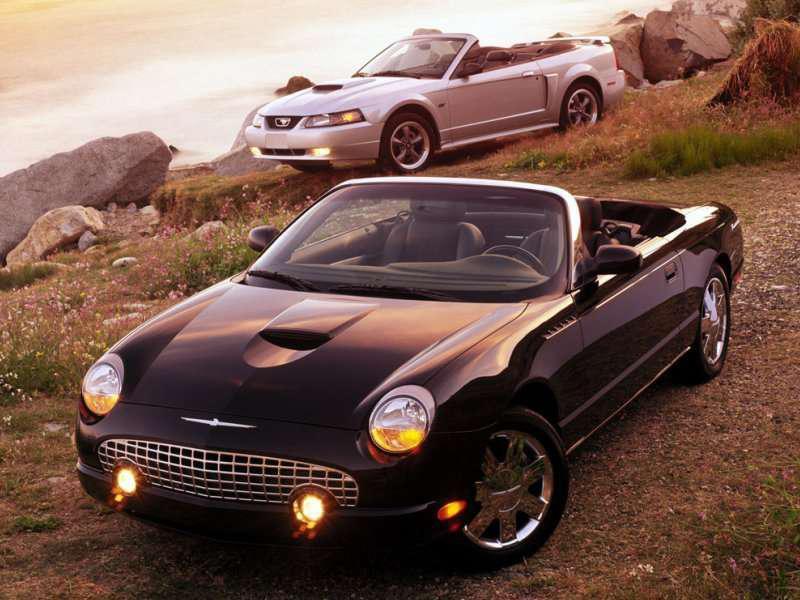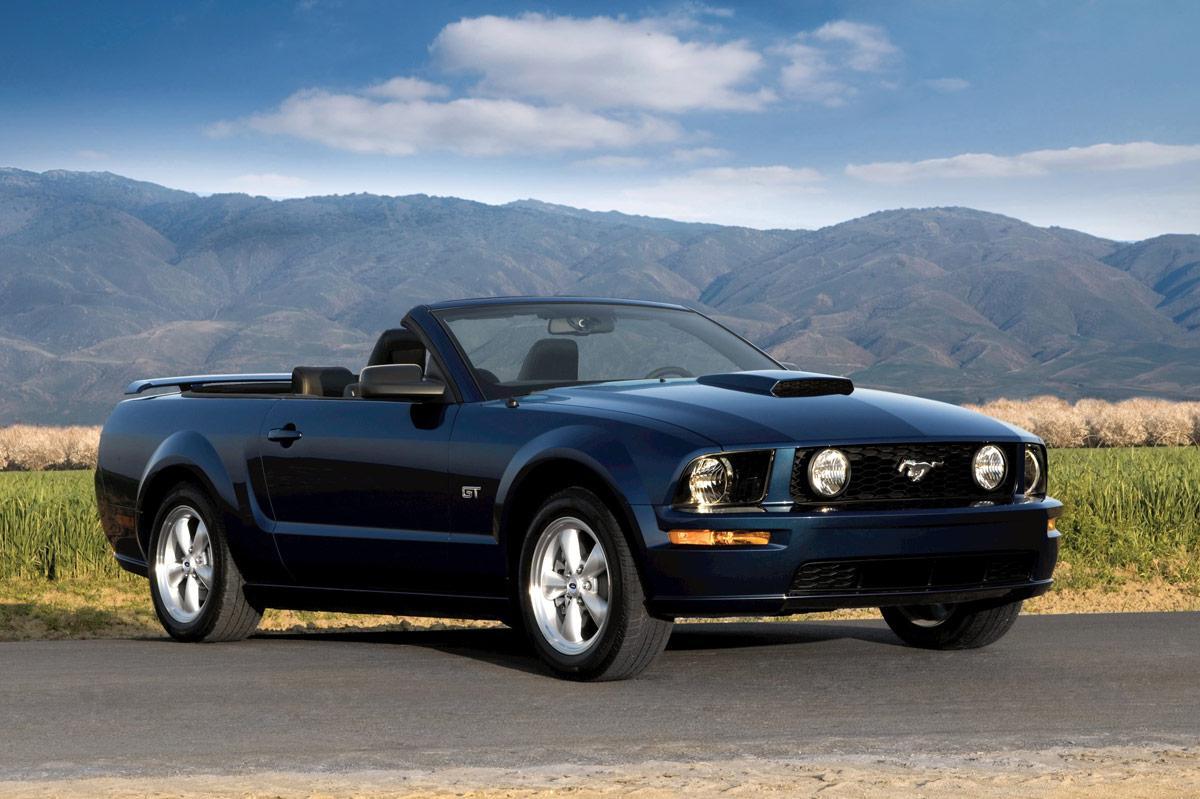The first image is the image on the left, the second image is the image on the right. Assess this claim about the two images: "there is a car parked on the street in front of a house". Correct or not? Answer yes or no. No. The first image is the image on the left, the second image is the image on the right. Analyze the images presented: Is the assertion "There is 1 or more silver cars on the road." valid? Answer yes or no. No. 